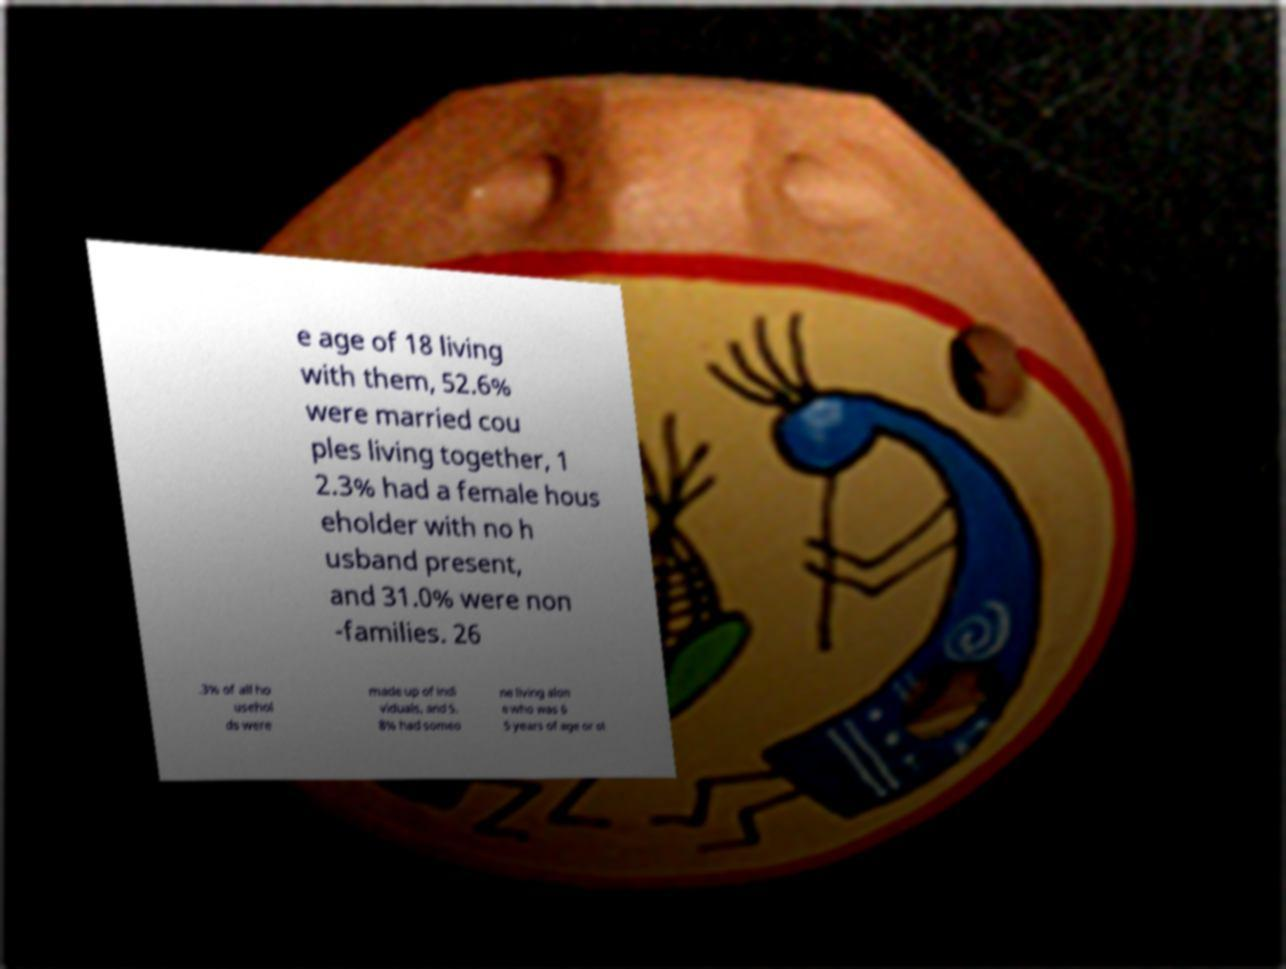Can you accurately transcribe the text from the provided image for me? e age of 18 living with them, 52.6% were married cou ples living together, 1 2.3% had a female hous eholder with no h usband present, and 31.0% were non -families. 26 .3% of all ho usehol ds were made up of indi viduals, and 5. 8% had someo ne living alon e who was 6 5 years of age or ol 